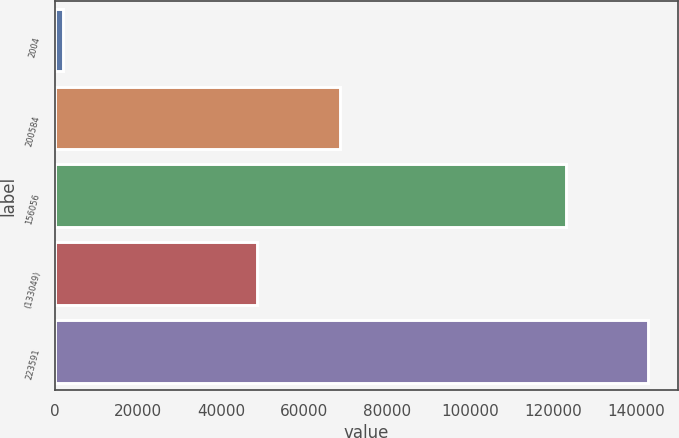Convert chart. <chart><loc_0><loc_0><loc_500><loc_500><bar_chart><fcel>2004<fcel>200584<fcel>156056<fcel>(133049)<fcel>223591<nl><fcel>2002<fcel>68595<fcel>123086<fcel>48697<fcel>142984<nl></chart> 